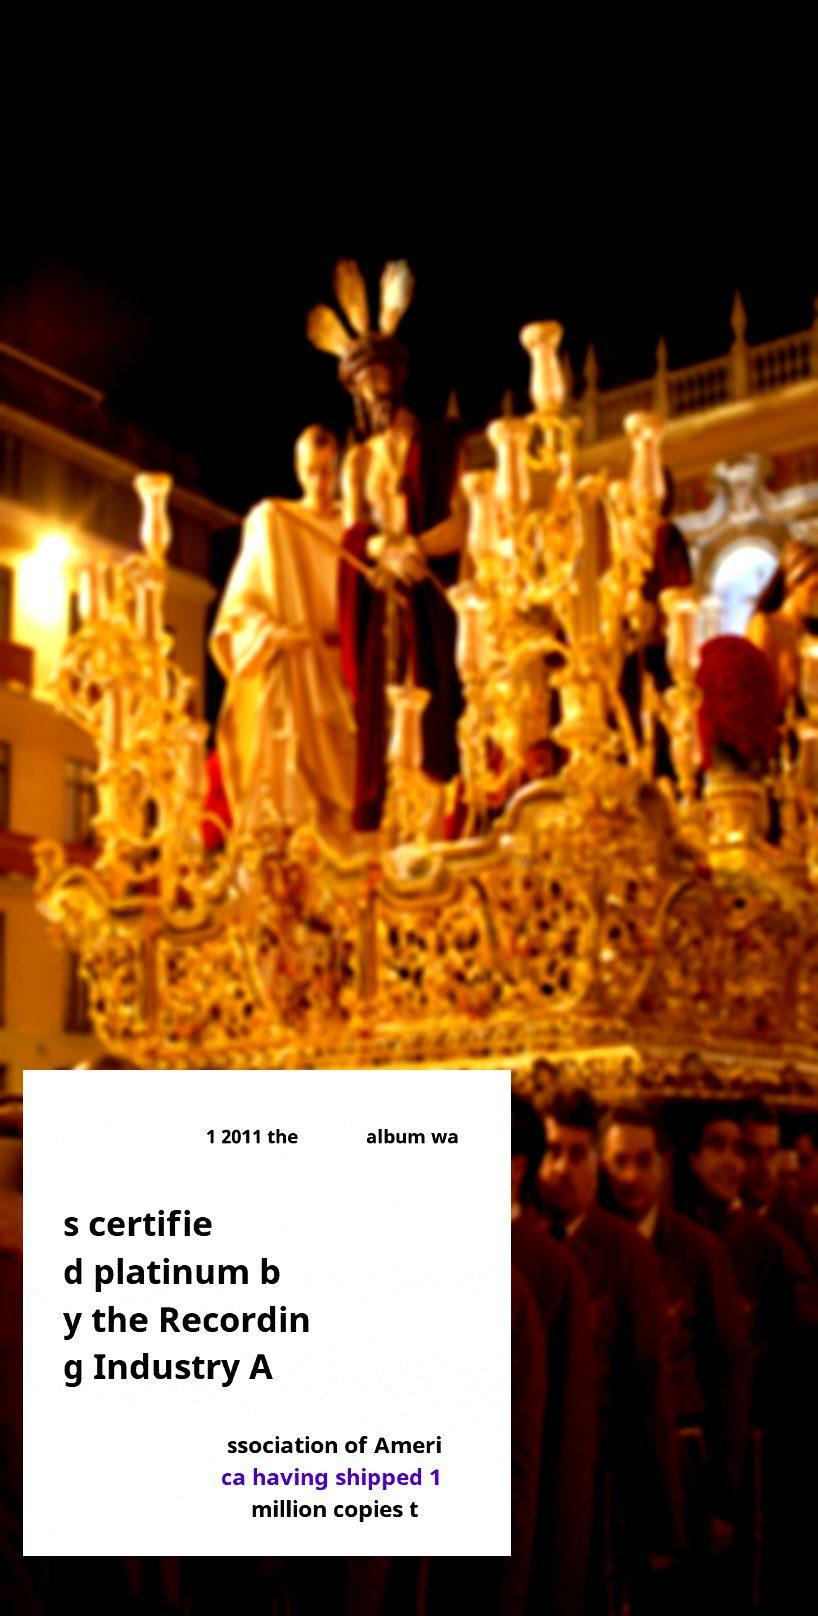For documentation purposes, I need the text within this image transcribed. Could you provide that? 1 2011 the album wa s certifie d platinum b y the Recordin g Industry A ssociation of Ameri ca having shipped 1 million copies t 